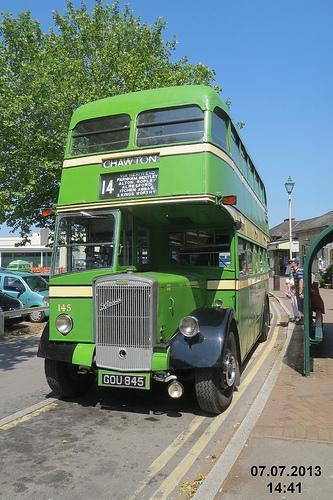How many buses are in the picture?
Give a very brief answer. 1. 